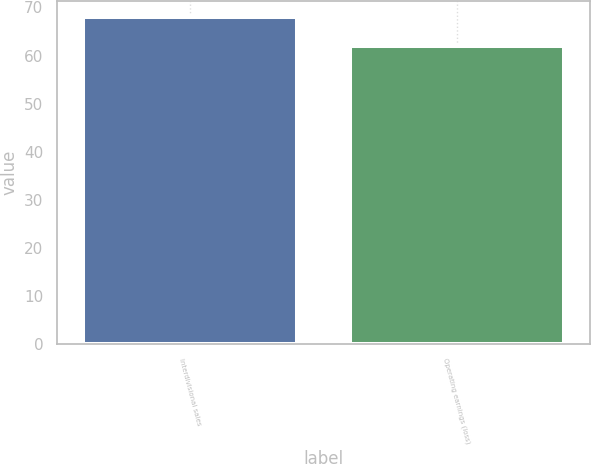Convert chart. <chart><loc_0><loc_0><loc_500><loc_500><bar_chart><fcel>Interdivisional sales<fcel>Operating earnings (loss)<nl><fcel>68<fcel>62<nl></chart> 